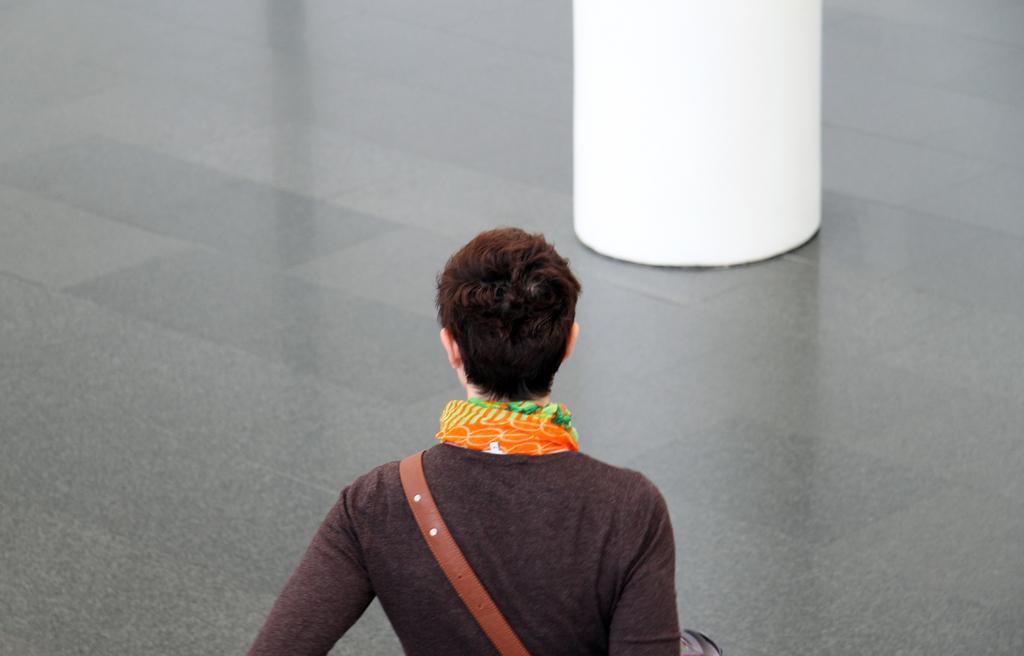Describe this image in one or two sentences. In this picture there is a woman who is wearing scarf, t-shirt and bag. She is standing on the floor. At the top there is a pillar. 